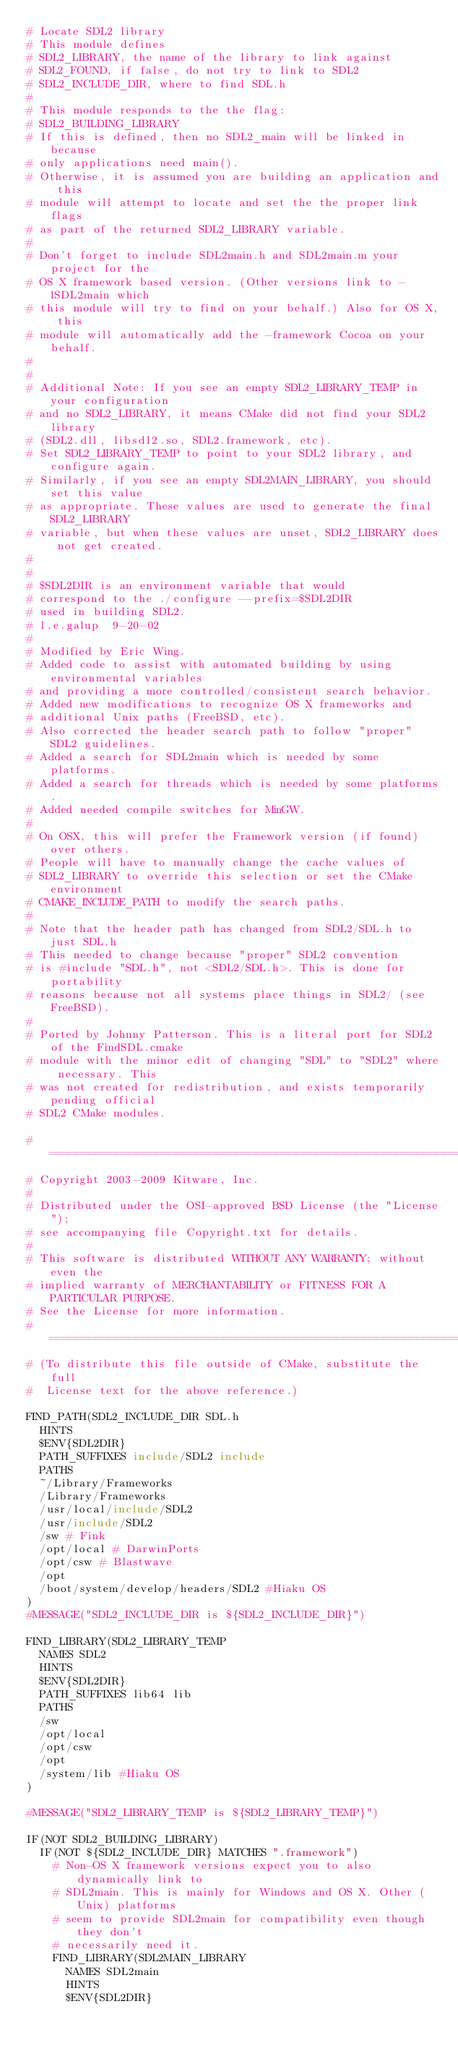Convert code to text. <code><loc_0><loc_0><loc_500><loc_500><_CMake_># Locate SDL2 library
# This module defines
# SDL2_LIBRARY, the name of the library to link against
# SDL2_FOUND, if false, do not try to link to SDL2
# SDL2_INCLUDE_DIR, where to find SDL.h
#
# This module responds to the the flag:
# SDL2_BUILDING_LIBRARY
# If this is defined, then no SDL2_main will be linked in because
# only applications need main().
# Otherwise, it is assumed you are building an application and this
# module will attempt to locate and set the the proper link flags
# as part of the returned SDL2_LIBRARY variable.
#
# Don't forget to include SDL2main.h and SDL2main.m your project for the
# OS X framework based version. (Other versions link to -lSDL2main which
# this module will try to find on your behalf.) Also for OS X, this
# module will automatically add the -framework Cocoa on your behalf.
#
#
# Additional Note: If you see an empty SDL2_LIBRARY_TEMP in your configuration
# and no SDL2_LIBRARY, it means CMake did not find your SDL2 library
# (SDL2.dll, libsdl2.so, SDL2.framework, etc).
# Set SDL2_LIBRARY_TEMP to point to your SDL2 library, and configure again.
# Similarly, if you see an empty SDL2MAIN_LIBRARY, you should set this value
# as appropriate. These values are used to generate the final SDL2_LIBRARY
# variable, but when these values are unset, SDL2_LIBRARY does not get created.
#
#
# $SDL2DIR is an environment variable that would
# correspond to the ./configure --prefix=$SDL2DIR
# used in building SDL2.
# l.e.galup  9-20-02
#
# Modified by Eric Wing.
# Added code to assist with automated building by using environmental variables
# and providing a more controlled/consistent search behavior.
# Added new modifications to recognize OS X frameworks and
# additional Unix paths (FreeBSD, etc).
# Also corrected the header search path to follow "proper" SDL2 guidelines.
# Added a search for SDL2main which is needed by some platforms.
# Added a search for threads which is needed by some platforms.
# Added needed compile switches for MinGW.
#
# On OSX, this will prefer the Framework version (if found) over others.
# People will have to manually change the cache values of
# SDL2_LIBRARY to override this selection or set the CMake environment
# CMAKE_INCLUDE_PATH to modify the search paths.
#
# Note that the header path has changed from SDL2/SDL.h to just SDL.h
# This needed to change because "proper" SDL2 convention
# is #include "SDL.h", not <SDL2/SDL.h>. This is done for portability
# reasons because not all systems place things in SDL2/ (see FreeBSD).
#
# Ported by Johnny Patterson. This is a literal port for SDL2 of the FindSDL.cmake
# module with the minor edit of changing "SDL" to "SDL2" where necessary. This
# was not created for redistribution, and exists temporarily pending official
# SDL2 CMake modules.

#=============================================================================
# Copyright 2003-2009 Kitware, Inc.
#
# Distributed under the OSI-approved BSD License (the "License");
# see accompanying file Copyright.txt for details.
#
# This software is distributed WITHOUT ANY WARRANTY; without even the
# implied warranty of MERCHANTABILITY or FITNESS FOR A PARTICULAR PURPOSE.
# See the License for more information.
#=============================================================================
# (To distribute this file outside of CMake, substitute the full
#  License text for the above reference.)

FIND_PATH(SDL2_INCLUDE_DIR SDL.h
  HINTS
  $ENV{SDL2DIR}
  PATH_SUFFIXES include/SDL2 include
  PATHS
  ~/Library/Frameworks
  /Library/Frameworks
  /usr/local/include/SDL2
  /usr/include/SDL2
  /sw # Fink
  /opt/local # DarwinPorts
  /opt/csw # Blastwave
  /opt
  /boot/system/develop/headers/SDL2 #Hiaku OS
)
#MESSAGE("SDL2_INCLUDE_DIR is ${SDL2_INCLUDE_DIR}")

FIND_LIBRARY(SDL2_LIBRARY_TEMP
  NAMES SDL2
  HINTS
  $ENV{SDL2DIR}
  PATH_SUFFIXES lib64 lib
  PATHS
  /sw
  /opt/local
  /opt/csw
  /opt
  /system/lib #Hiaku OS
)

#MESSAGE("SDL2_LIBRARY_TEMP is ${SDL2_LIBRARY_TEMP}")

IF(NOT SDL2_BUILDING_LIBRARY)
  IF(NOT ${SDL2_INCLUDE_DIR} MATCHES ".framework")
    # Non-OS X framework versions expect you to also dynamically link to
    # SDL2main. This is mainly for Windows and OS X. Other (Unix) platforms
    # seem to provide SDL2main for compatibility even though they don't
    # necessarily need it.
    FIND_LIBRARY(SDL2MAIN_LIBRARY
      NAMES SDL2main
      HINTS
      $ENV{SDL2DIR}</code> 